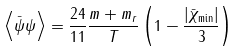Convert formula to latex. <formula><loc_0><loc_0><loc_500><loc_500>\left \langle \bar { \psi } \psi \right \rangle = \frac { 2 4 } { 1 1 } \frac { m + m _ { r } } T \left ( 1 - \frac { \left | \bar { \chi } _ { \min } \right | } 3 \right )</formula> 